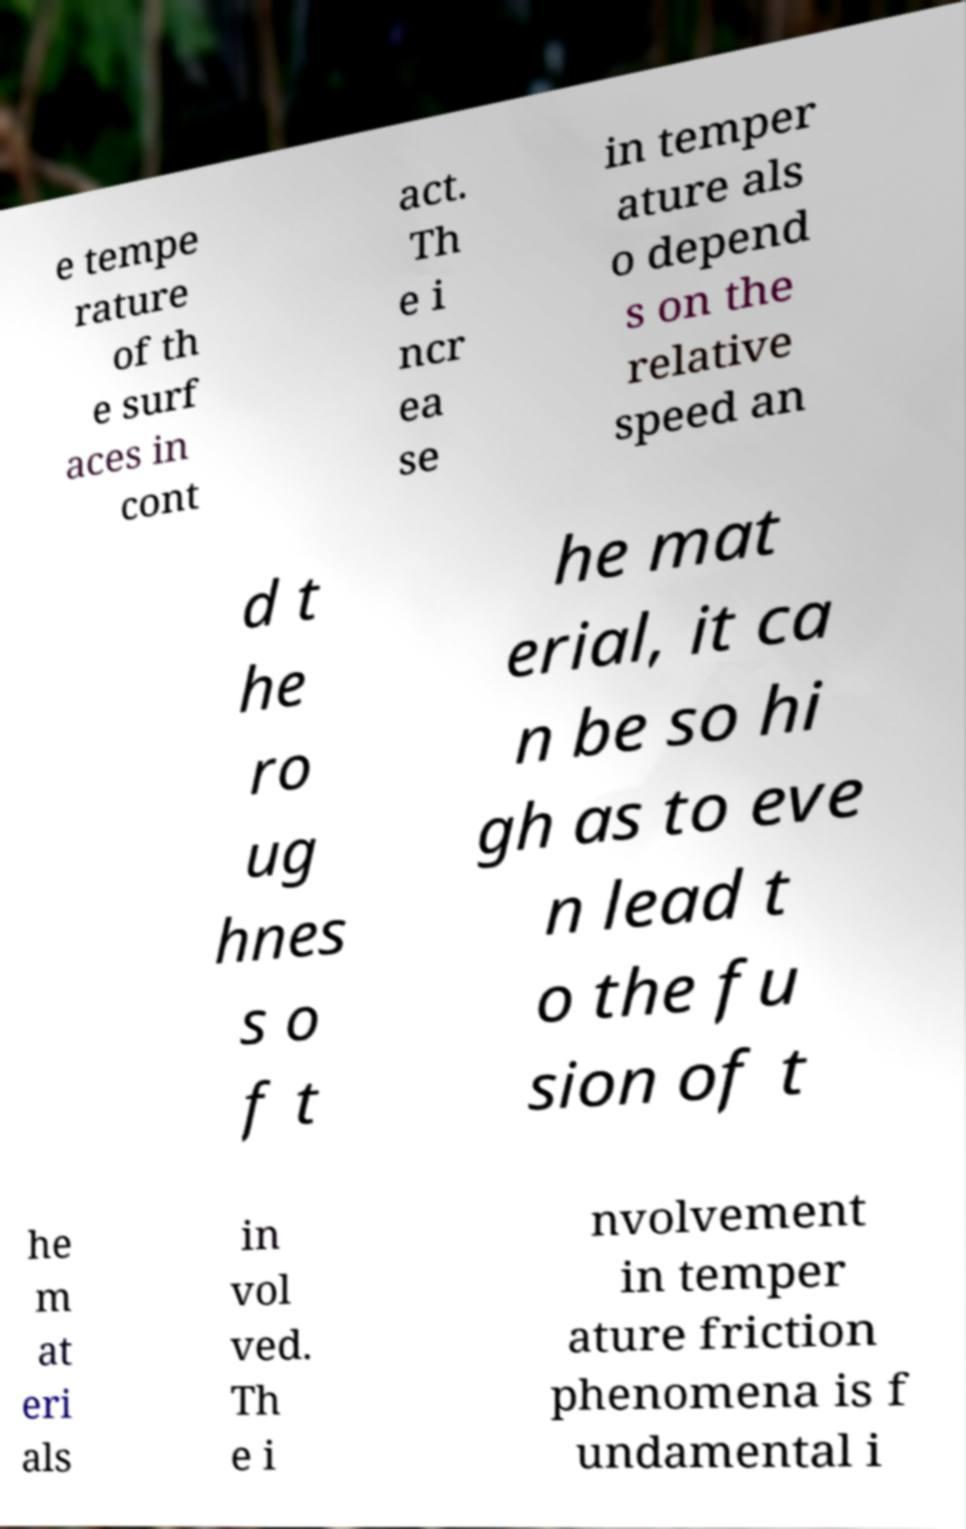Can you accurately transcribe the text from the provided image for me? e tempe rature of th e surf aces in cont act. Th e i ncr ea se in temper ature als o depend s on the relative speed an d t he ro ug hnes s o f t he mat erial, it ca n be so hi gh as to eve n lead t o the fu sion of t he m at eri als in vol ved. Th e i nvolvement in temper ature friction phenomena is f undamental i 